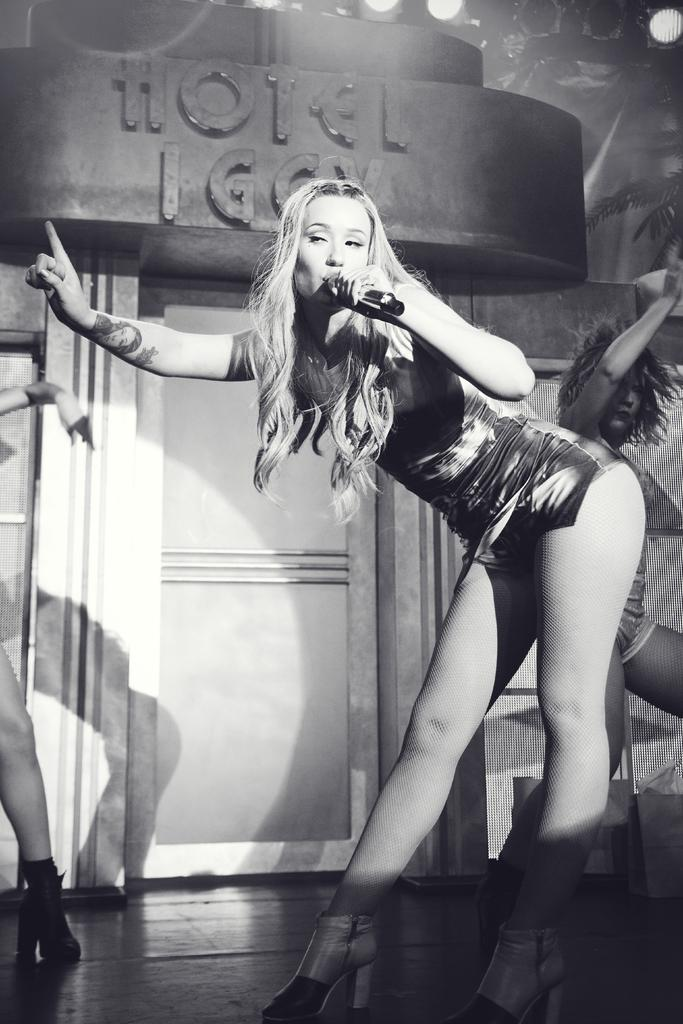What is the color scheme of the image? The image is black and white. Who is present in the image? There is a woman in the image. What is the woman doing in the image? The woman is talking on a microphone. How many girls are present in the image? There is no girl present in the image; it features a woman. What type of produce is being harvested in the image? There is no produce or harvesting activity depicted in the image. 